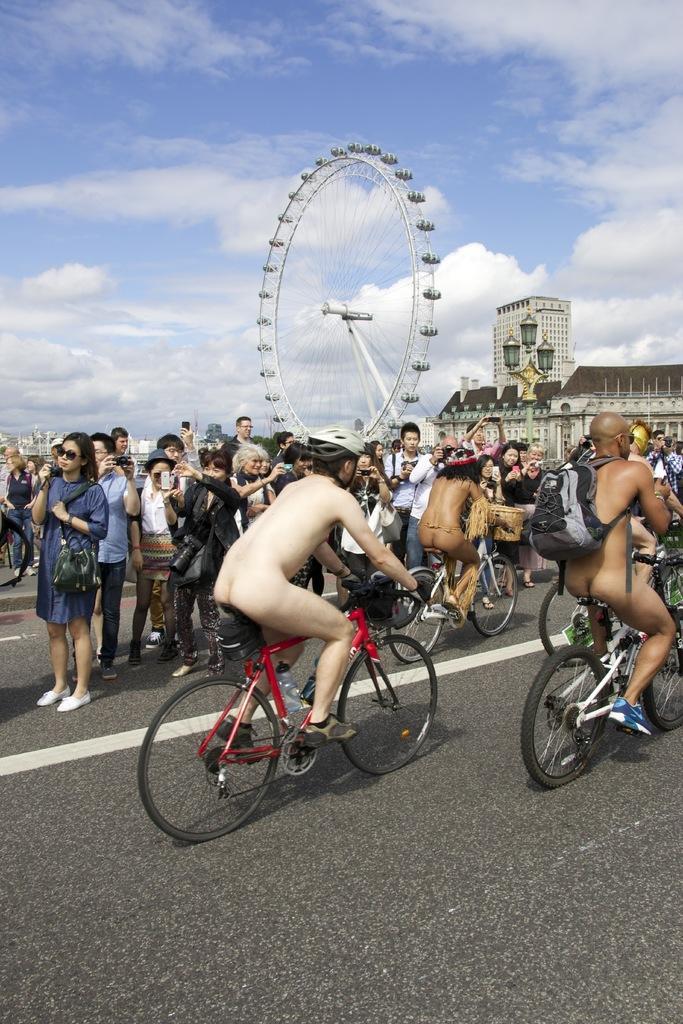How would you summarize this image in a sentence or two? In this image I can see number of people and few of them are cycling their cycles. Here I can see one person is carrying a bag. In the background I can see a building, a giant wheel and clear view of sky. 